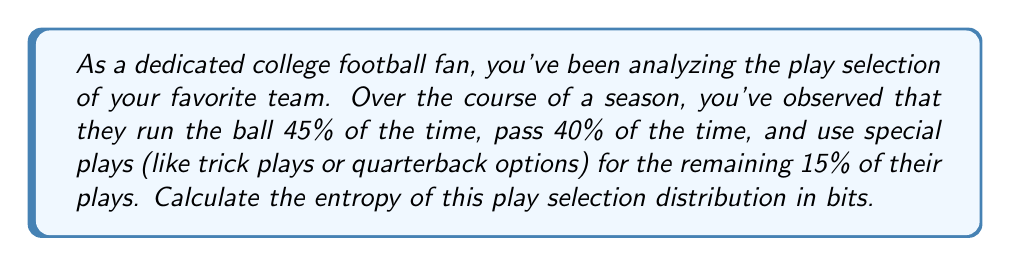Solve this math problem. To calculate the entropy of the play selection distribution, we'll use the formula for Shannon entropy:

$$H = -\sum_{i=1}^n p_i \log_2(p_i)$$

Where:
- $H$ is the entropy in bits
- $p_i$ is the probability of each event
- $n$ is the number of possible events

In this case, we have three types of plays:
1. Run: $p_1 = 0.45$
2. Pass: $p_2 = 0.40$
3. Special plays: $p_3 = 0.15$

Let's calculate each term:

1. $-p_1 \log_2(p_1) = -0.45 \log_2(0.45) = 0.5159$
2. $-p_2 \log_2(p_2) = -0.40 \log_2(0.40) = 0.5288$
3. $-p_3 \log_2(p_3) = -0.15 \log_2(0.15) = 0.4105$

Now, we sum these terms:

$$H = 0.5159 + 0.5288 + 0.4105 = 1.4552$$

Therefore, the entropy of the play selection distribution is approximately 1.4552 bits.
Answer: 1.4552 bits 